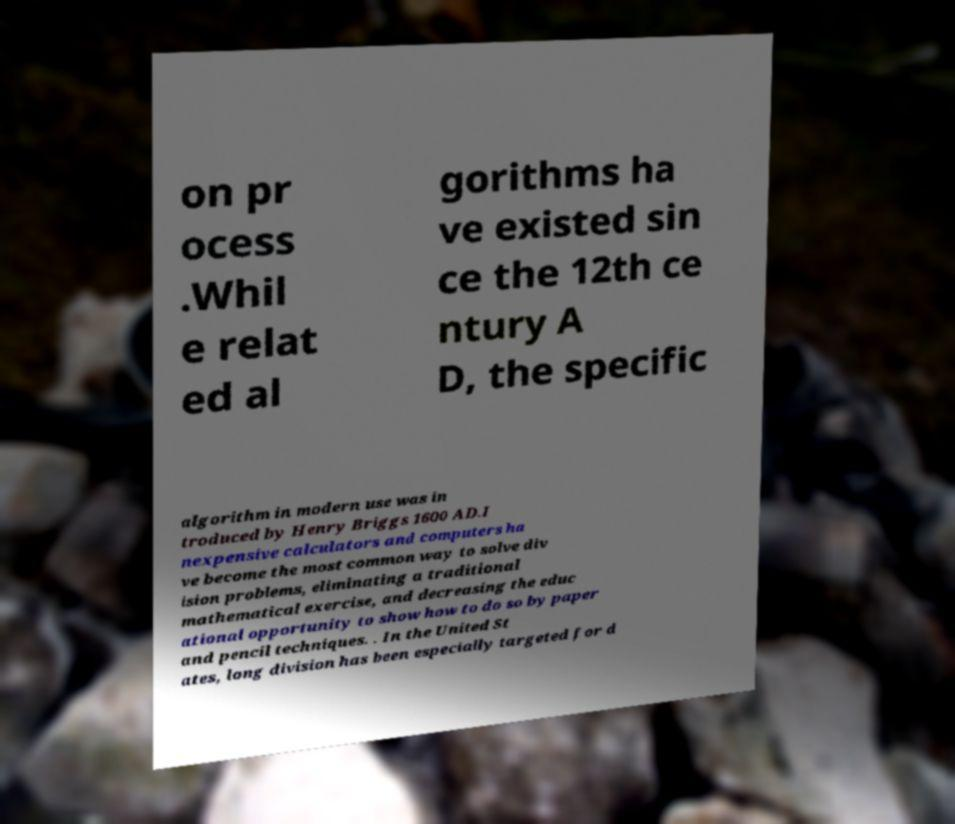What messages or text are displayed in this image? I need them in a readable, typed format. on pr ocess .Whil e relat ed al gorithms ha ve existed sin ce the 12th ce ntury A D, the specific algorithm in modern use was in troduced by Henry Briggs 1600 AD.I nexpensive calculators and computers ha ve become the most common way to solve div ision problems, eliminating a traditional mathematical exercise, and decreasing the educ ational opportunity to show how to do so by paper and pencil techniques. . In the United St ates, long division has been especially targeted for d 